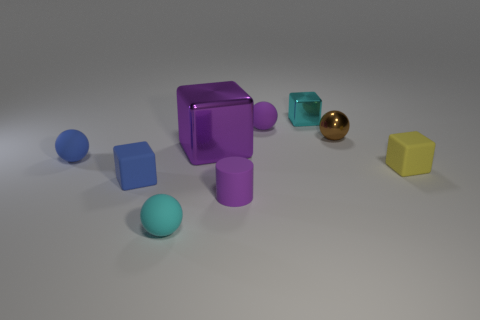Subtract all small matte spheres. How many spheres are left? 1 Subtract all purple cubes. How many cubes are left? 3 Subtract all spheres. How many objects are left? 5 Add 1 small purple things. How many objects exist? 10 Subtract 1 cubes. How many cubes are left? 3 Subtract all cyan spheres. Subtract all tiny blue matte balls. How many objects are left? 7 Add 5 small blue spheres. How many small blue spheres are left? 6 Add 8 cyan rubber objects. How many cyan rubber objects exist? 9 Subtract 0 red cylinders. How many objects are left? 9 Subtract all yellow cylinders. Subtract all red cubes. How many cylinders are left? 1 